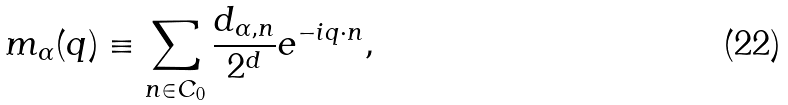<formula> <loc_0><loc_0><loc_500><loc_500>m _ { \alpha } ( q ) \equiv \sum _ { n \in C _ { 0 } } \frac { d _ { \alpha , n } } { 2 ^ { d } } e ^ { - i q \cdot n } ,</formula> 